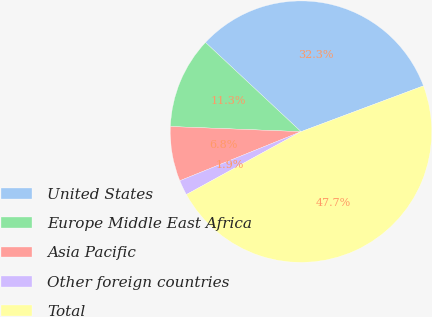Convert chart to OTSL. <chart><loc_0><loc_0><loc_500><loc_500><pie_chart><fcel>United States<fcel>Europe Middle East Africa<fcel>Asia Pacific<fcel>Other foreign countries<fcel>Total<nl><fcel>32.34%<fcel>11.33%<fcel>6.75%<fcel>1.86%<fcel>47.71%<nl></chart> 